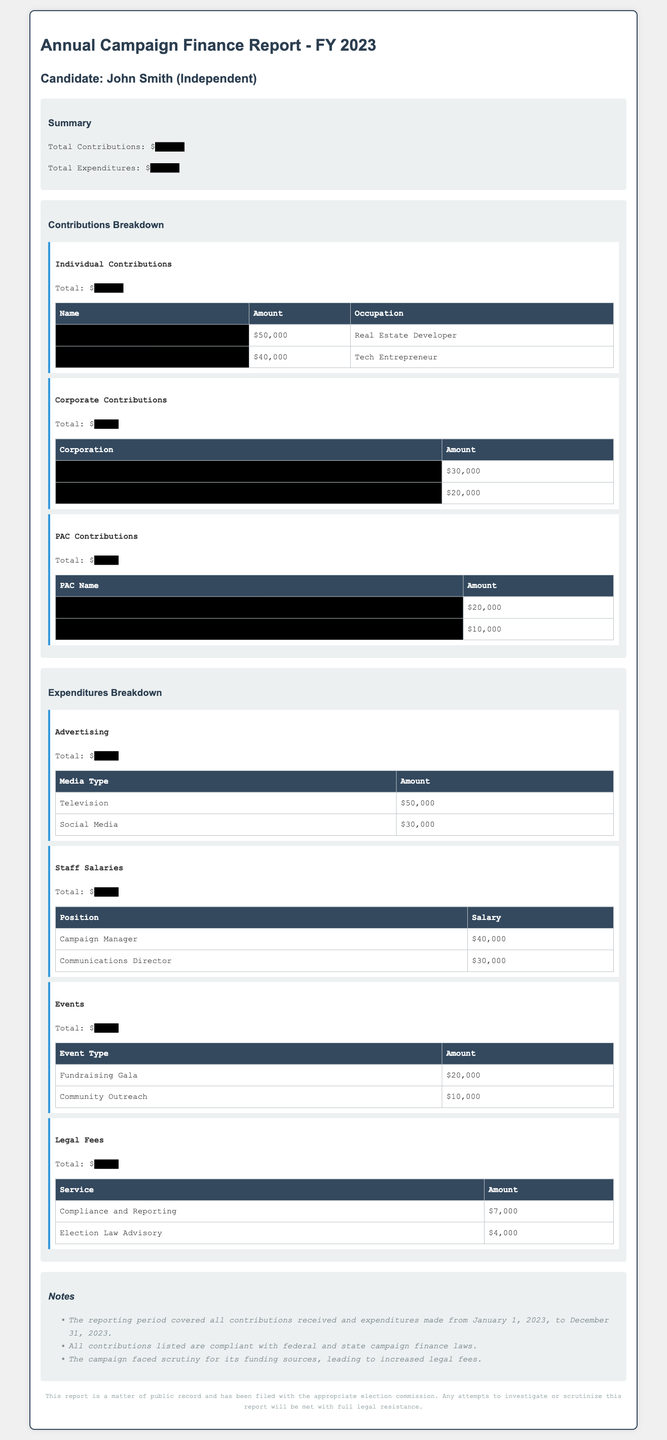What is the total amount of individual contributions? The individual contributions are detailed in the contributions breakdown, which lists a total of $150,000.
Answer: $150,000 What is the amount spent on advertising? The expenditures breakdown includes a total for advertising, which is listed as $80,000.
Answer: $80,000 Who contributed the largest amount to the campaign? The individual contributions section indicates that Rachel Green contributed the largest amount at $50,000.
Answer: Rachel Green What is the total amount of corporate contributions? The corporate contributions section shows a total of $60,000.
Answer: $60,000 Which event had the highest expenditure? The events subsection reveals that the Fundraising Gala had the highest expenditure at $20,000.
Answer: Fundraising Gala How much was spent on legal fees? The expenditures listed show a total for legal fees as $11,000.
Answer: $11,000 What is the total of PAC contributions? The PAC contributions section shows a total of $40,000.
Answer: $40,000 How many categories are there in the contributions breakdown? The contributions breakdown contains three categories: Individual Contributions, Corporate Contributions, and PAC Contributions.
Answer: Three What is noted about the campaign's funding sources? One of the notes in the document states that the campaign faced scrutiny for its funding sources.
Answer: Scrutiny for funding sources 